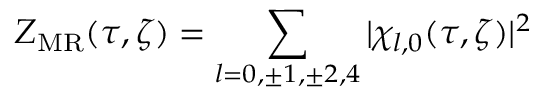<formula> <loc_0><loc_0><loc_500><loc_500>Z _ { M R } ( \tau , \zeta ) = \sum _ { l = 0 , \pm 1 , \pm 2 , 4 } | \chi _ { l , 0 } ( \tau , \zeta ) | ^ { 2 }</formula> 